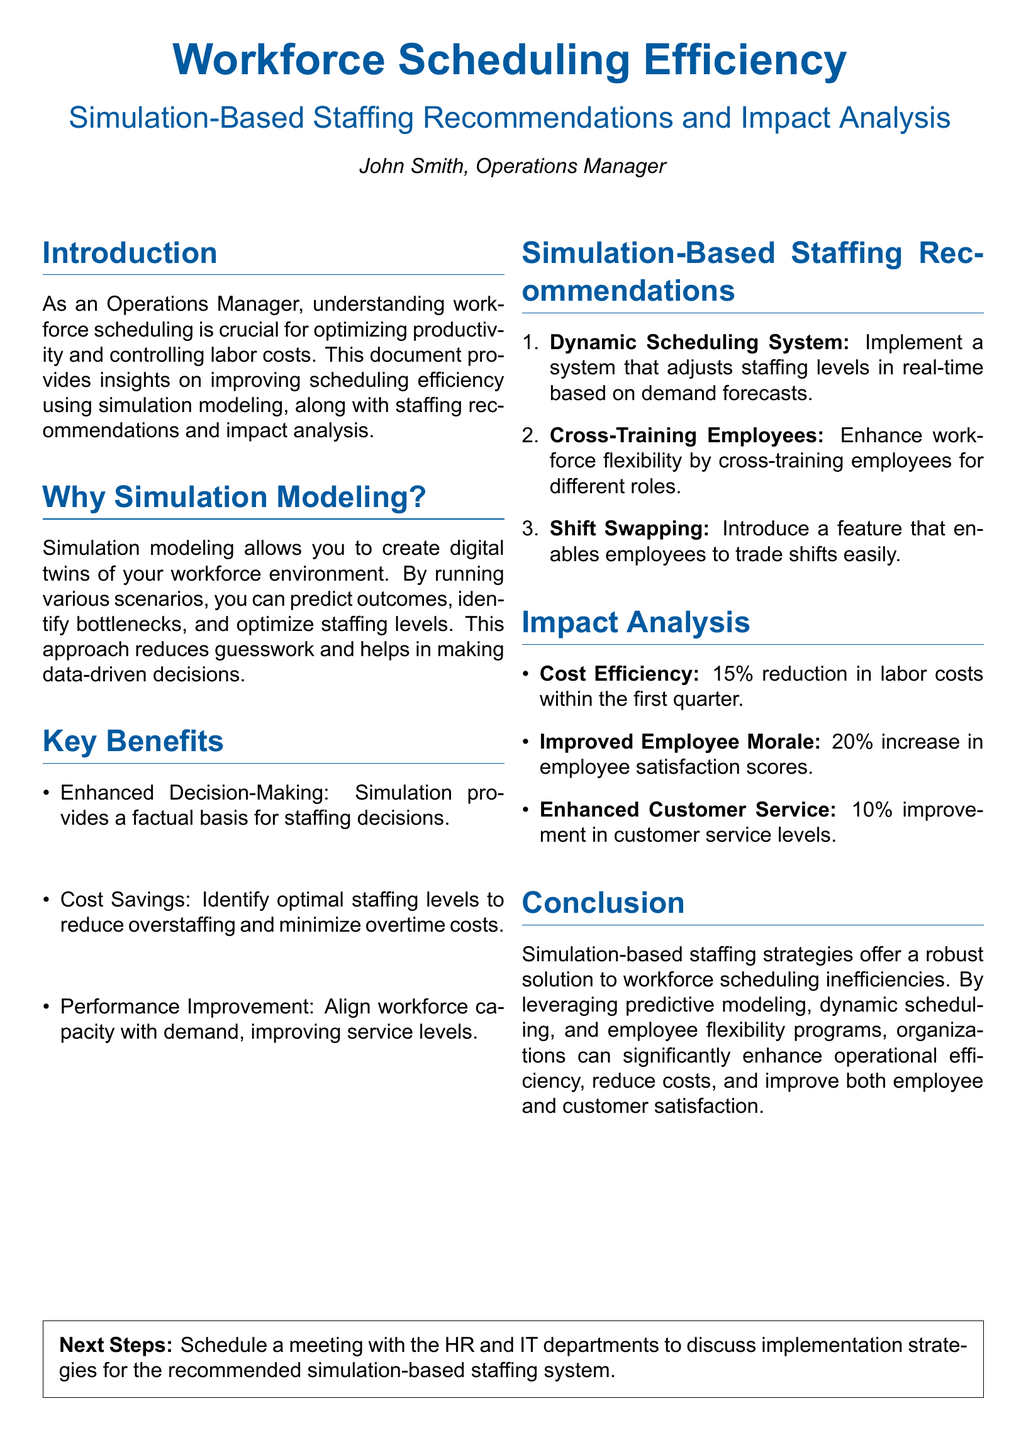What is the main focus of the document? The document focuses on improving workforce scheduling efficiency through simulation modeling.
Answer: Workforce Scheduling Efficiency Who authored the document? The document is authored by John Smith, who is an Operations Manager.
Answer: John Smith What percentage reduction in labor costs is mentioned in the impact analysis? The impact analysis states a 15% reduction in labor costs within the first quarter.
Answer: 15% What is one of the key benefits of simulation modeling listed in the document? One of the key benefits listed is Enhanced Decision-Making.
Answer: Enhanced Decision-Making What system is recommended for staffing level adjustments? The document recommends a Dynamic Scheduling System for real-time staffing level adjustments.
Answer: Dynamic Scheduling System What increase in employee satisfaction scores is reported? The impact analysis mentions a 20% increase in employee satisfaction scores.
Answer: 20% Which feature is suggested for improving workforce flexibility? The document suggests cross-training employees as a feature to enhance workforce flexibility.
Answer: Cross-Training Employees What is the primary conclusion drawn in the document? The primary conclusion is that simulation-based staffing strategies significantly enhance operational efficiency.
Answer: Operational efficiency What percentage improvement in customer service levels is noted? The document reports a 10% improvement in customer service levels.
Answer: 10% 